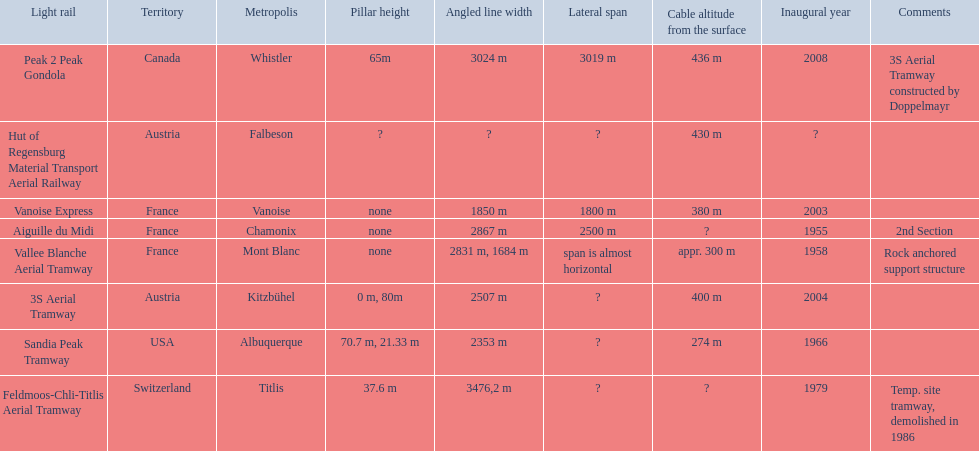What are all of the tramways? Peak 2 Peak Gondola, Hut of Regensburg Material Transport Aerial Railway, Vanoise Express, Aiguille du Midi, Vallee Blanche Aerial Tramway, 3S Aerial Tramway, Sandia Peak Tramway, Feldmoos-Chli-Titlis Aerial Tramway. When were they inaugurated? 2008, ?, 2003, 1955, 1958, 2004, 1966, 1979. Write the full table. {'header': ['Light rail', 'Territory', 'Metropolis', 'Pillar height', 'Angled line width', 'Lateral span', 'Cable altitude from the surface', 'Inaugural year', 'Comments'], 'rows': [['Peak 2 Peak Gondola', 'Canada', 'Whistler', '65m', '3024 m', '3019 m', '436 m', '2008', '3S Aerial Tramway constructed by Doppelmayr'], ['Hut of Regensburg Material Transport Aerial Railway', 'Austria', 'Falbeson', '?', '?', '?', '430 m', '?', ''], ['Vanoise Express', 'France', 'Vanoise', 'none', '1850 m', '1800 m', '380 m', '2003', ''], ['Aiguille du Midi', 'France', 'Chamonix', 'none', '2867 m', '2500 m', '?', '1955', '2nd Section'], ['Vallee Blanche Aerial Tramway', 'France', 'Mont Blanc', 'none', '2831 m, 1684 m', 'span is almost horizontal', 'appr. 300 m', '1958', 'Rock anchored support structure'], ['3S Aerial Tramway', 'Austria', 'Kitzbühel', '0 m, 80m', '2507 m', '?', '400 m', '2004', ''], ['Sandia Peak Tramway', 'USA', 'Albuquerque', '70.7 m, 21.33 m', '2353 m', '?', '274 m', '1966', ''], ['Feldmoos-Chli-Titlis Aerial Tramway', 'Switzerland', 'Titlis', '37.6 m', '3476,2 m', '?', '?', '1979', 'Temp. site tramway, demolished in 1986']]} Now, between 3s aerial tramway and aiguille du midi, which was inaugurated first? Aiguille du Midi. 